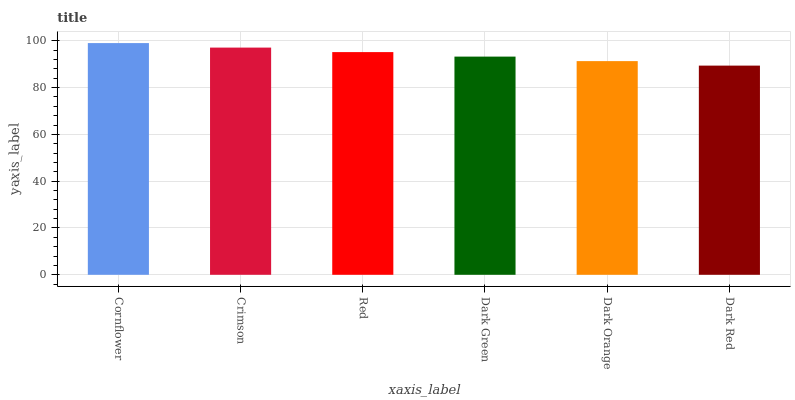Is Crimson the minimum?
Answer yes or no. No. Is Crimson the maximum?
Answer yes or no. No. Is Cornflower greater than Crimson?
Answer yes or no. Yes. Is Crimson less than Cornflower?
Answer yes or no. Yes. Is Crimson greater than Cornflower?
Answer yes or no. No. Is Cornflower less than Crimson?
Answer yes or no. No. Is Red the high median?
Answer yes or no. Yes. Is Dark Green the low median?
Answer yes or no. Yes. Is Dark Green the high median?
Answer yes or no. No. Is Red the low median?
Answer yes or no. No. 